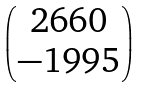<formula> <loc_0><loc_0><loc_500><loc_500>\begin{pmatrix} 2 6 6 0 \\ - 1 9 9 5 \end{pmatrix}</formula> 